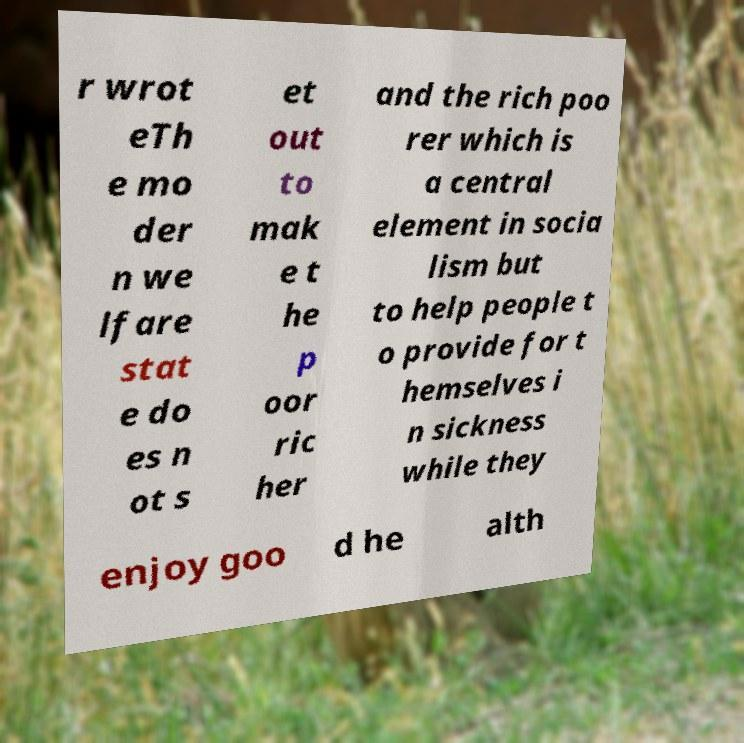Can you read and provide the text displayed in the image?This photo seems to have some interesting text. Can you extract and type it out for me? r wrot eTh e mo der n we lfare stat e do es n ot s et out to mak e t he p oor ric her and the rich poo rer which is a central element in socia lism but to help people t o provide for t hemselves i n sickness while they enjoy goo d he alth 